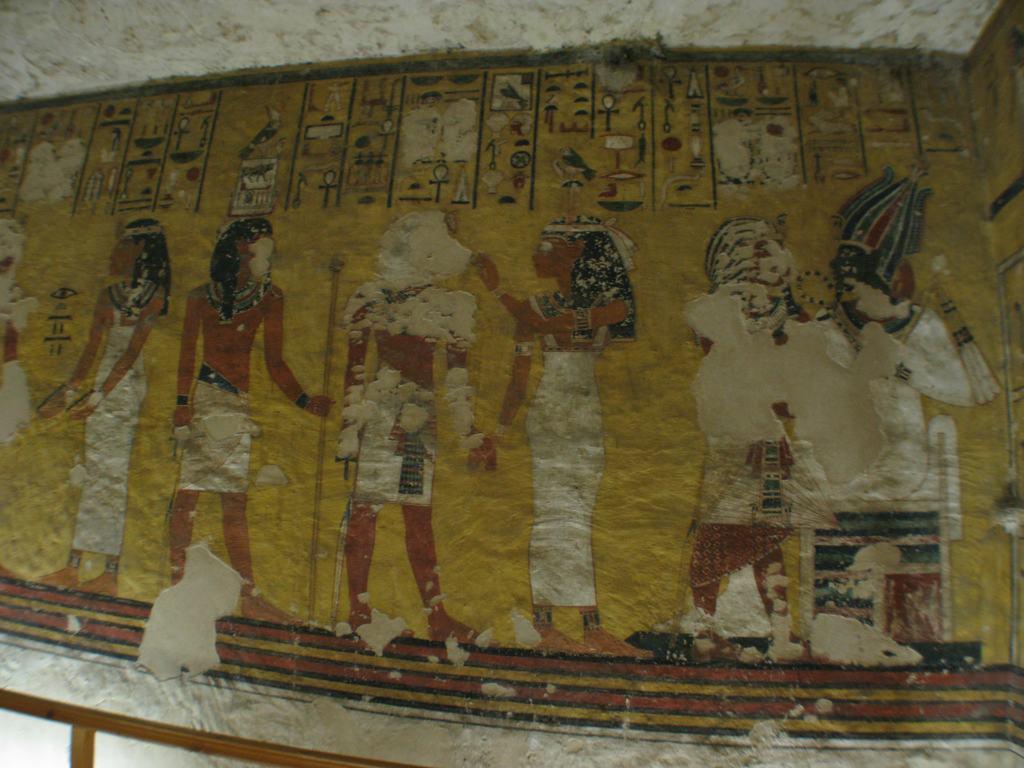How would you summarize this image in a sentence or two? In this image we can see paintings on the wall. 